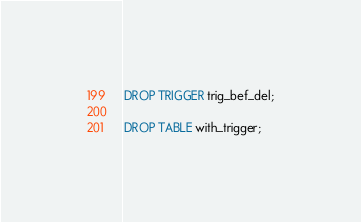Convert code to text. <code><loc_0><loc_0><loc_500><loc_500><_SQL_>
DROP TRIGGER trig_bef_del;

DROP TABLE with_trigger;
</code> 